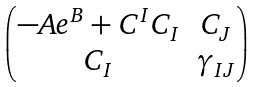<formula> <loc_0><loc_0><loc_500><loc_500>\begin{pmatrix} - A e ^ { B } + C ^ { I } C _ { I } & C _ { J } \\ C _ { I } & \gamma _ { I J } \end{pmatrix}</formula> 